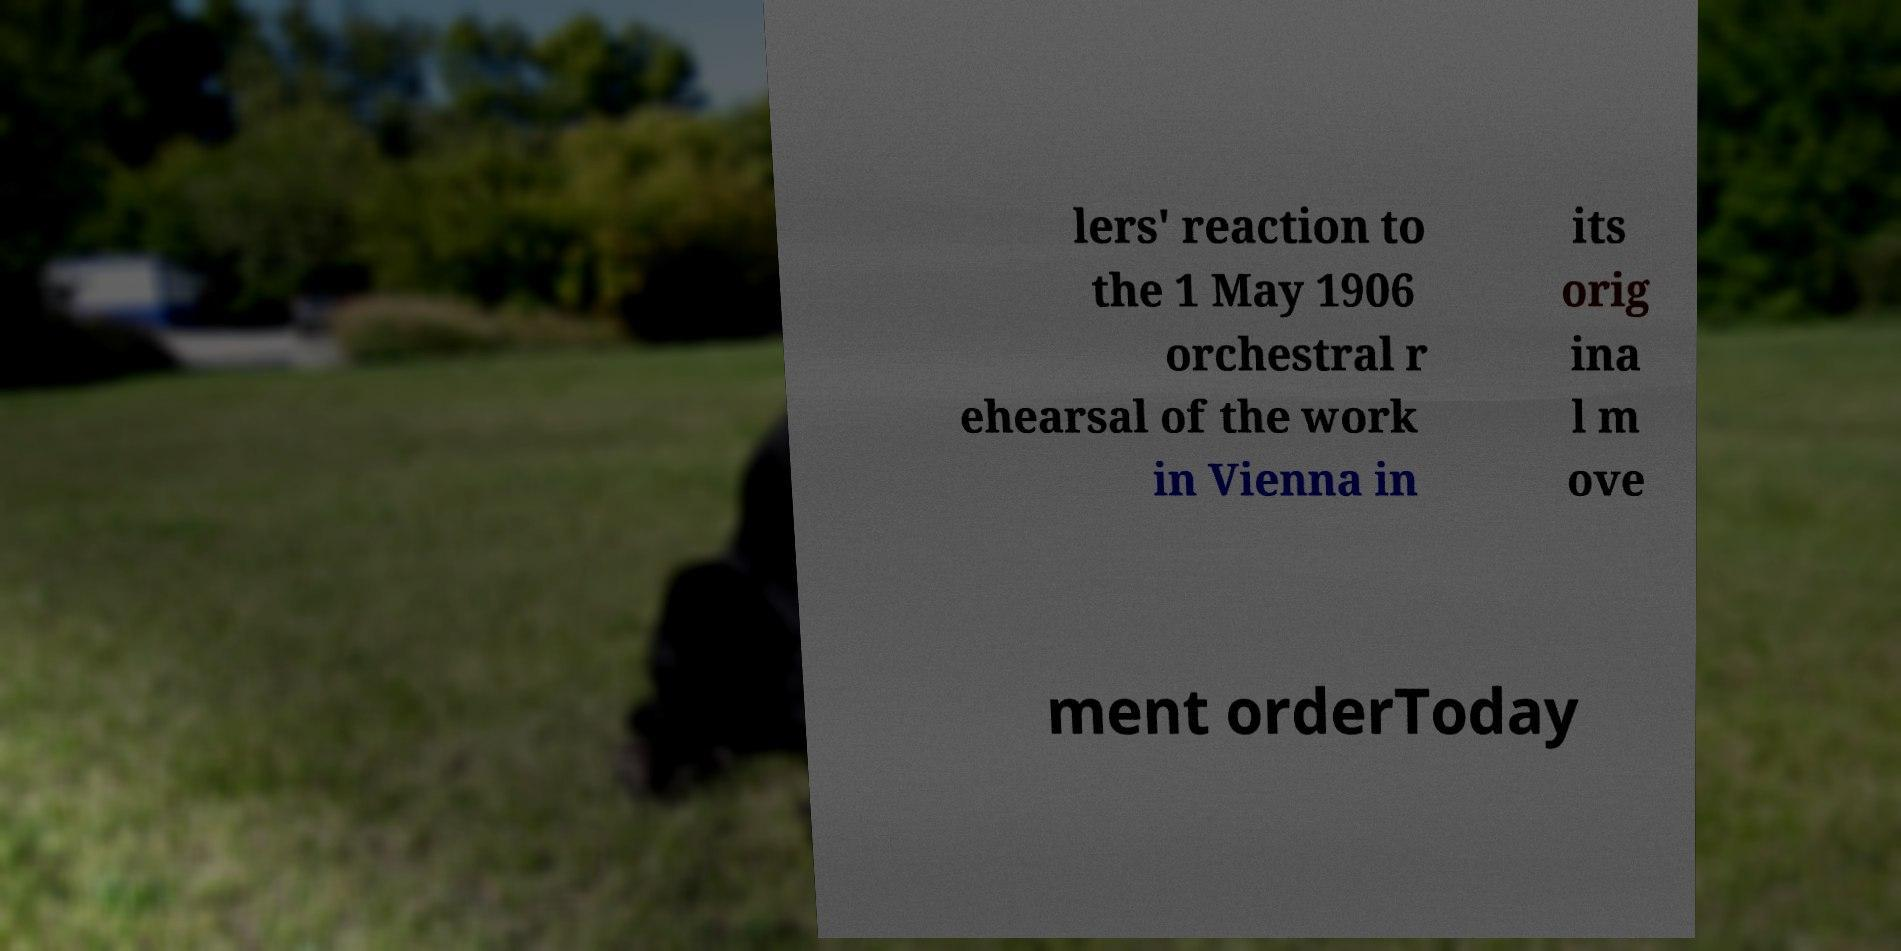Can you accurately transcribe the text from the provided image for me? lers' reaction to the 1 May 1906 orchestral r ehearsal of the work in Vienna in its orig ina l m ove ment orderToday 